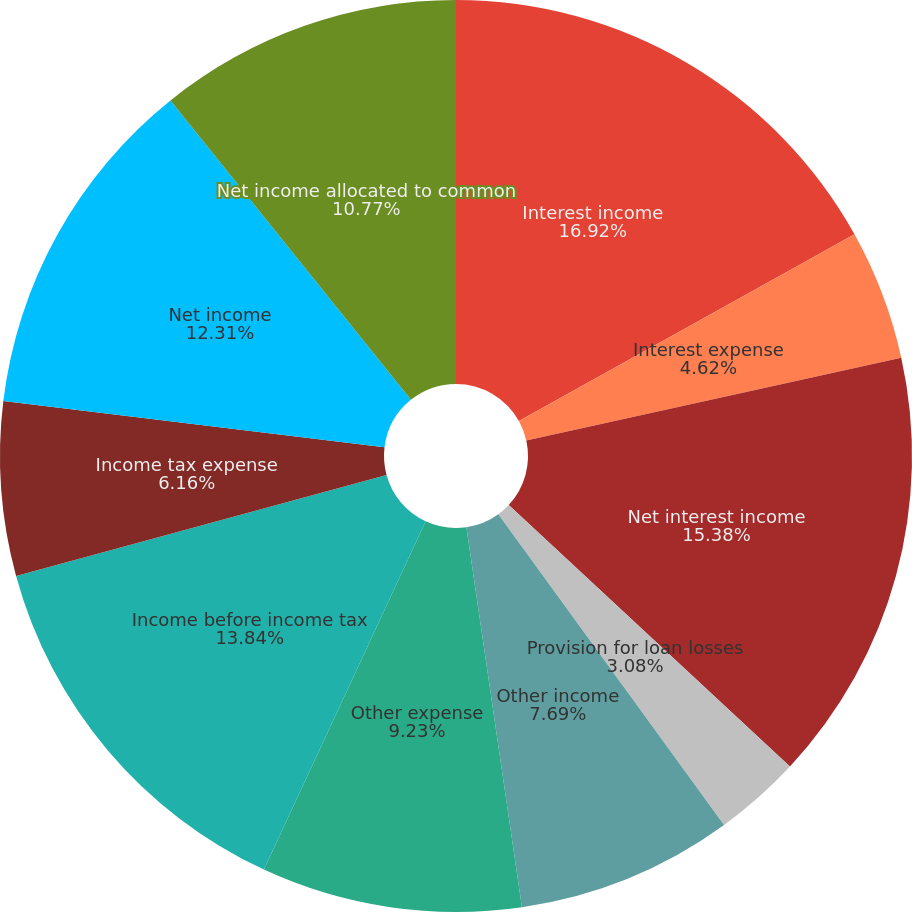Convert chart. <chart><loc_0><loc_0><loc_500><loc_500><pie_chart><fcel>Interest income<fcel>Interest expense<fcel>Net interest income<fcel>Provision for loan losses<fcel>Other income<fcel>Other expense<fcel>Income before income tax<fcel>Income tax expense<fcel>Net income<fcel>Net income allocated to common<nl><fcel>16.92%<fcel>4.62%<fcel>15.38%<fcel>3.08%<fcel>7.69%<fcel>9.23%<fcel>13.84%<fcel>6.16%<fcel>12.31%<fcel>10.77%<nl></chart> 